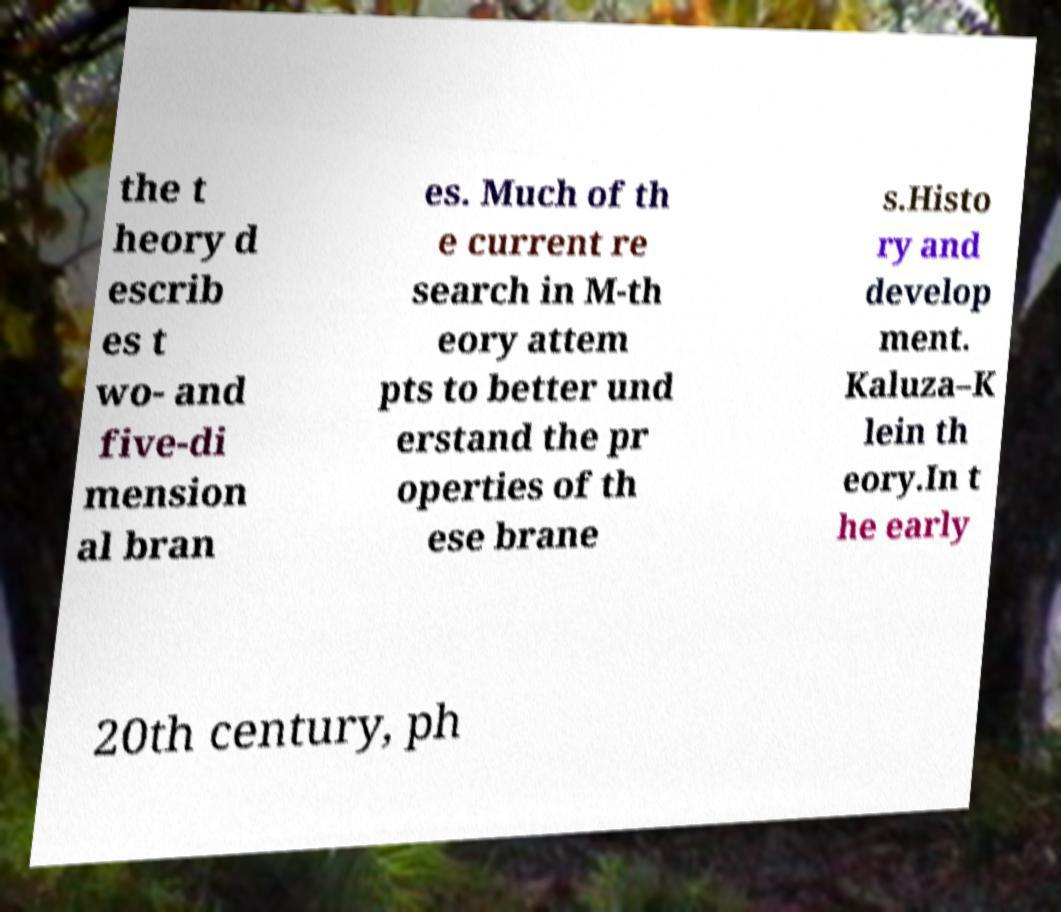Can you accurately transcribe the text from the provided image for me? the t heory d escrib es t wo- and five-di mension al bran es. Much of th e current re search in M-th eory attem pts to better und erstand the pr operties of th ese brane s.Histo ry and develop ment. Kaluza–K lein th eory.In t he early 20th century, ph 